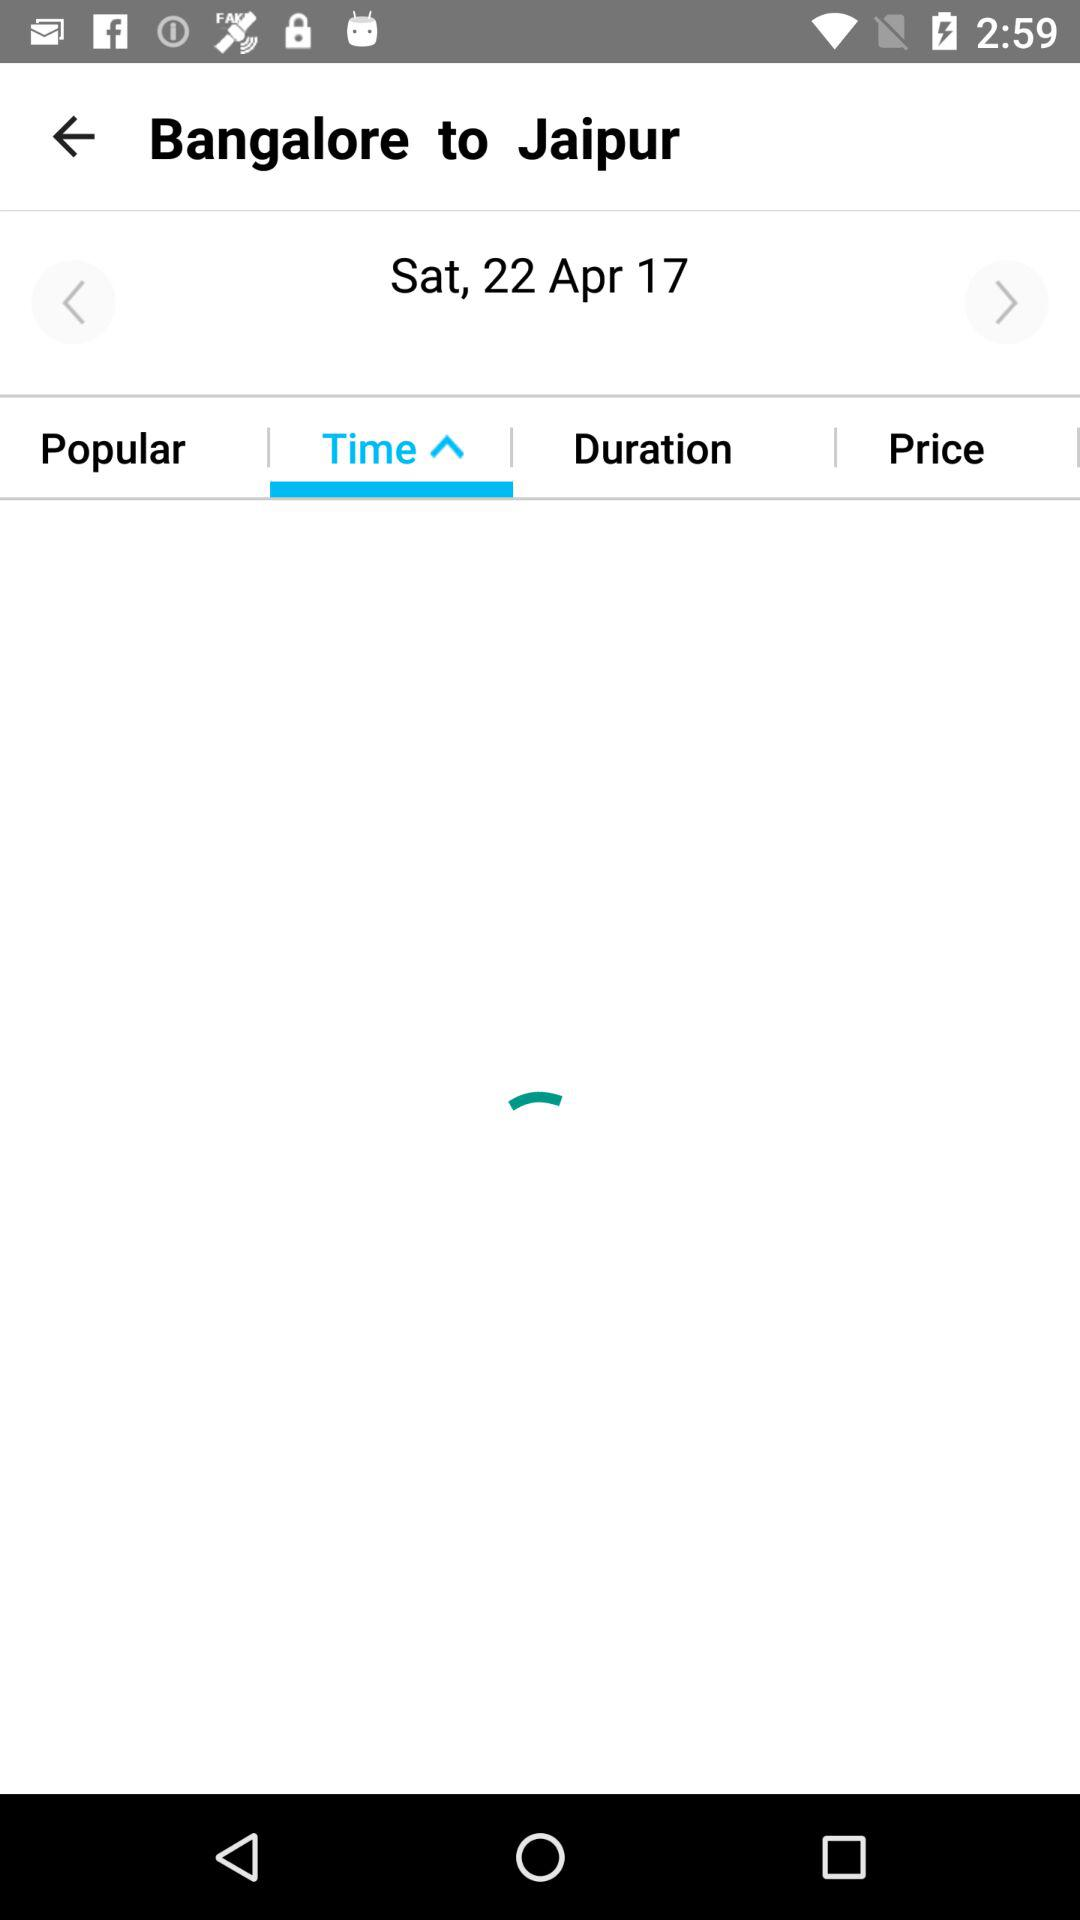What date is selected for travel? The selected date is Saturday, April 22, 2017. 